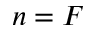<formula> <loc_0><loc_0><loc_500><loc_500>n = F</formula> 